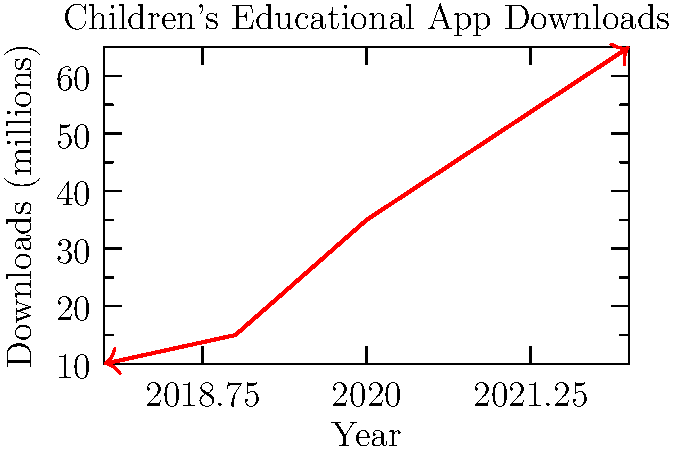Based on the line graph showing the growth of children's educational app downloads from 2018 to 2022, what was the approximate percentage increase in downloads between 2019 and 2020? To calculate the percentage increase in downloads between 2019 and 2020, we need to follow these steps:

1. Identify the number of downloads in 2019 and 2020:
   2019: 15 million
   2020: 35 million

2. Calculate the difference in downloads:
   35 million - 15 million = 20 million

3. Calculate the percentage increase:
   Percentage increase = (Increase / Original Value) × 100
   = (20 million / 15 million) × 100
   = 1.3333... × 100
   ≈ 133.33%

4. Round to the nearest whole percentage:
   133%

The percentage increase in children's educational app downloads between 2019 and 2020 was approximately 133%.
Answer: 133% 